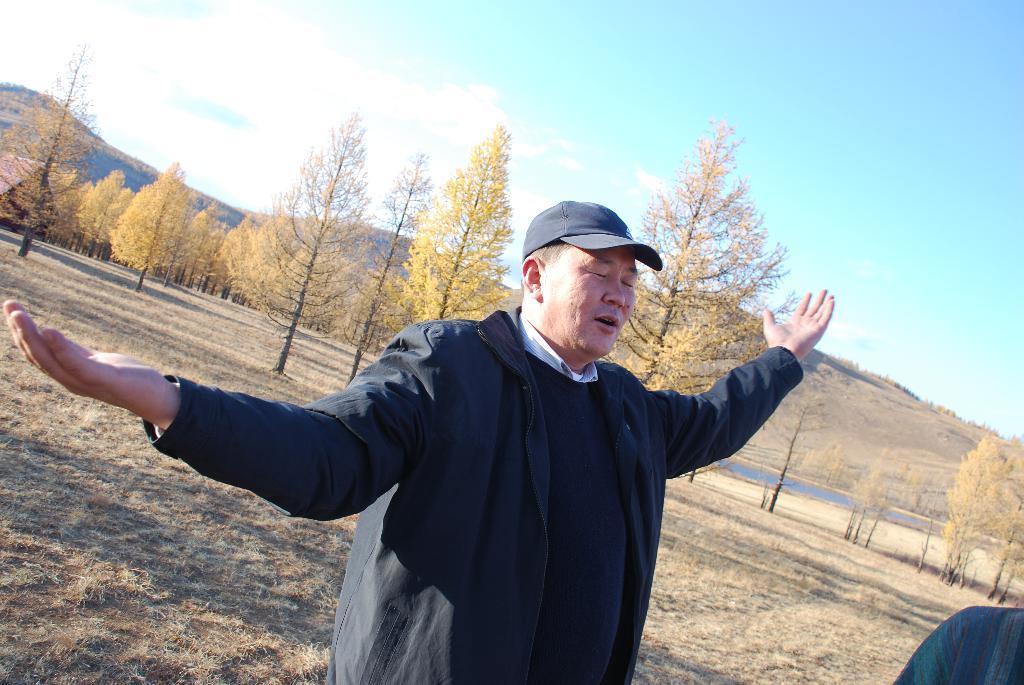Please provide a concise description of this image. This picture is taken from outside of the city and it is sunny. In this image, in the middle, we can see a man wearing a black dress is standing on the grass. In the right corner, we can see the arm of a person. In the background, we can see some trees, plants, rocks. At the top, we can see a sky, at the bottom, we can see a road and a grass. 